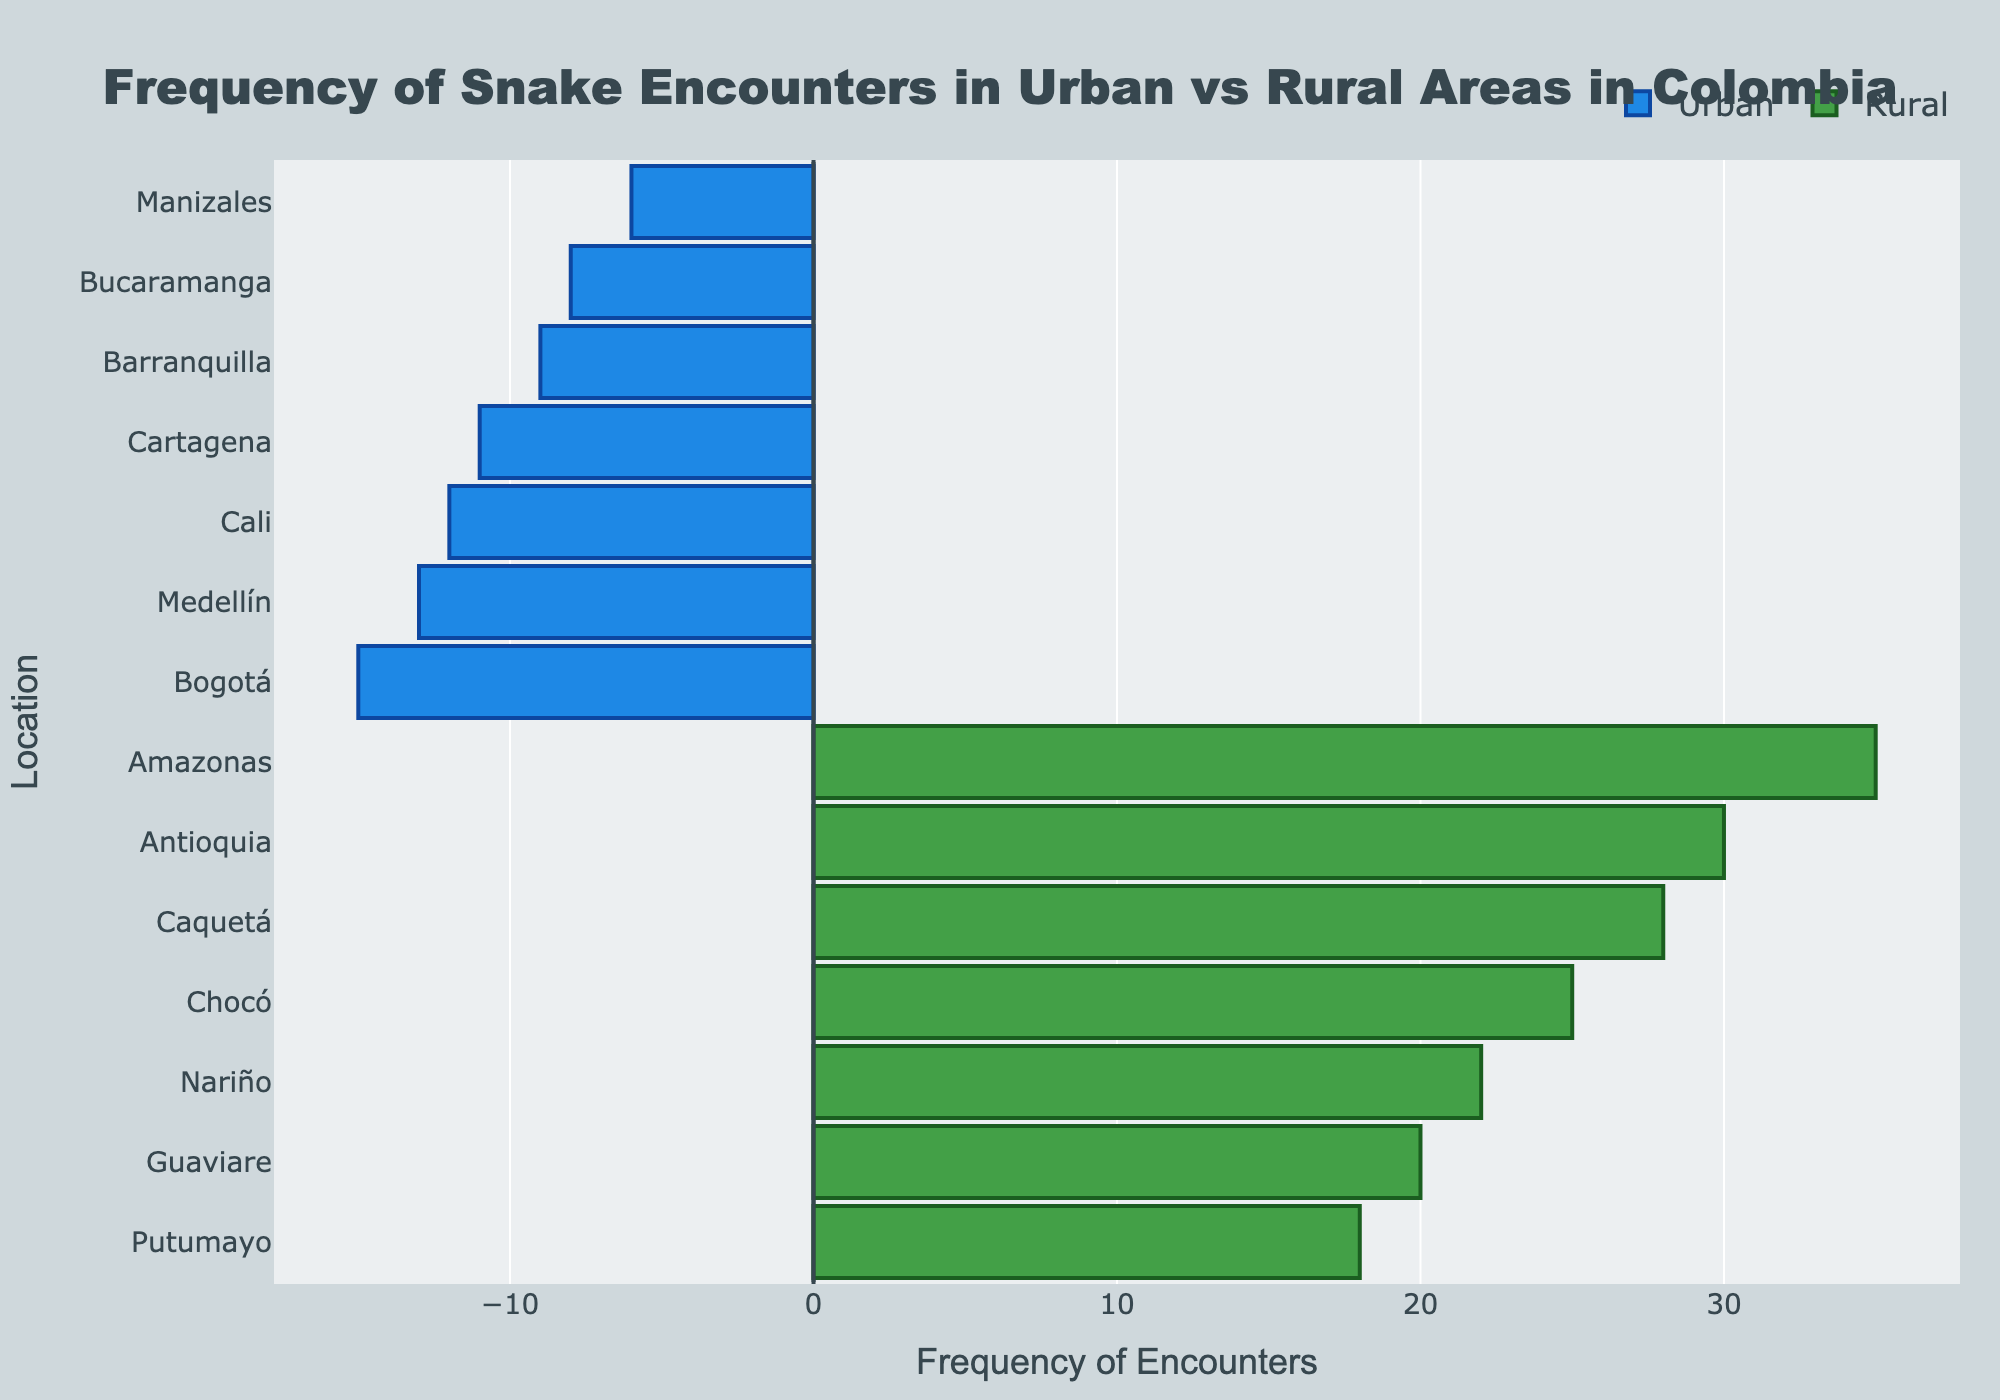Which location has the highest frequency of snake encounters in rural areas? The rural area with the tallest green bar represents the highest frequency of encounters, which is Amazonas with 35 encounters.
Answer: Amazonas Which urban location has the lowest frequency of snake encounters? The urban location with the shortest blue bar indicates the lowest frequency, which is Manizales with 6 encounters.
Answer: Manizales How much higher is the frequency of snake encounters in Amazonas compared to Bogotá? Compare the lengths of the bars representing Amazonas and Bogotá. Amazonas has 35 encounters while Bogotá has 15 encounters. The difference is 35 - 15 = 20 encounters.
Answer: 20 encounters What is the total frequency of snake encounters in rural areas? Sum the frequencies of all bars in rural areas: 35 + 30 + 28 + 25 + 22 + 20 + 18 = 178 encounters.
Answer: 178 encounters Which urban area has a higher frequency of snake encounters, Medellín or Cali? Compare the bars for Medellín and Cali in the urban section. Medellín has 13 encounters and Cali has 12 encounters, so Medellín has a higher frequency.
Answer: Medellín What is the average frequency of snake encounters in the urban locations? Sum the frequencies for all urban locations and divide by the number of locations: (15 + 13 + 12 + 9 + 11 + 8 + 6) / 7 = 74 / 7 ≈ 10.57 encounters.
Answer: 10.57 encounters By how much does the frequency of snake encounters in Cartagena exceed that in Bucaramanga? Subtract the frequency of encounters in Bucaramanga from that in Cartagena: 11 - 8 = 3 encounters.
Answer: 3 encounters 